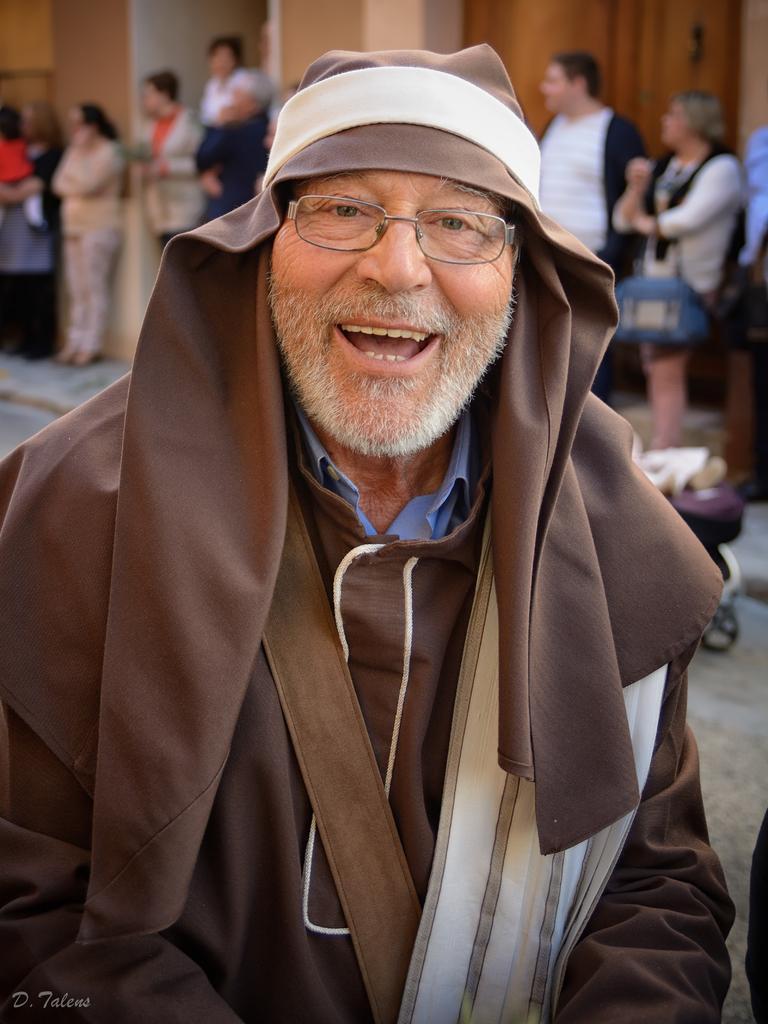How would you summarize this image in a sentence or two? This is the man standing and smiling. In the background, I can see groups of people standing. This looks like a building. I can see the watermark on the image. 